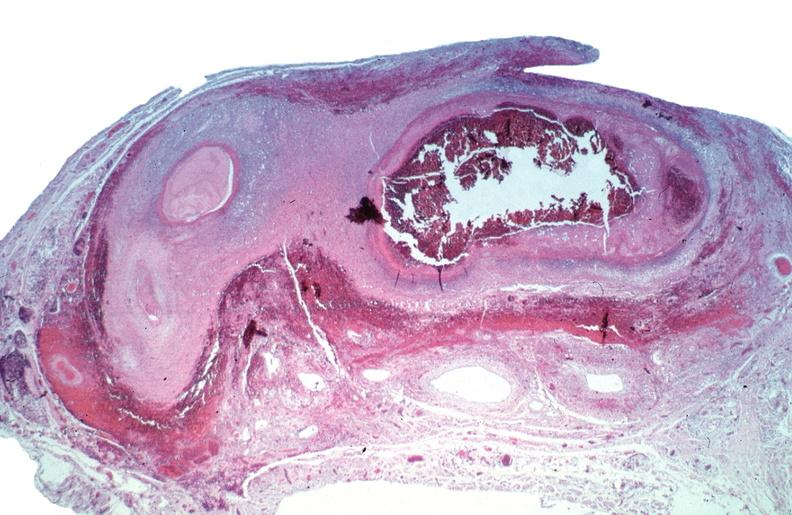what is present?
Answer the question using a single word or phrase. Cardiovascular 